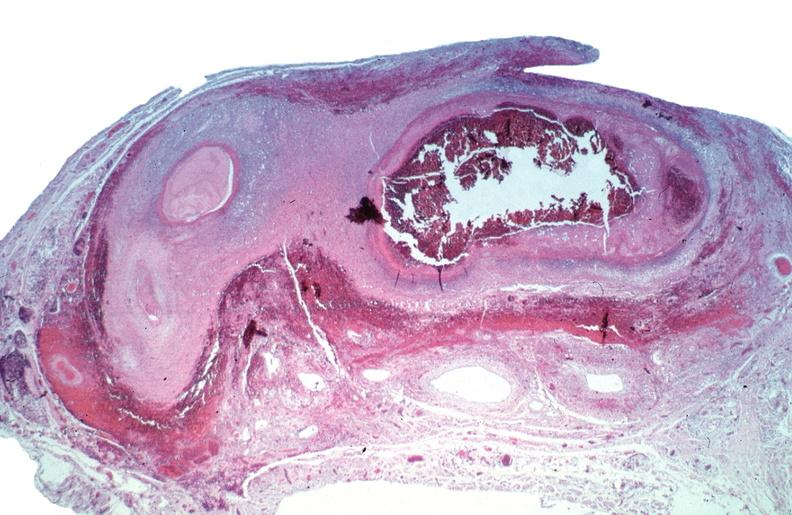what is present?
Answer the question using a single word or phrase. Cardiovascular 